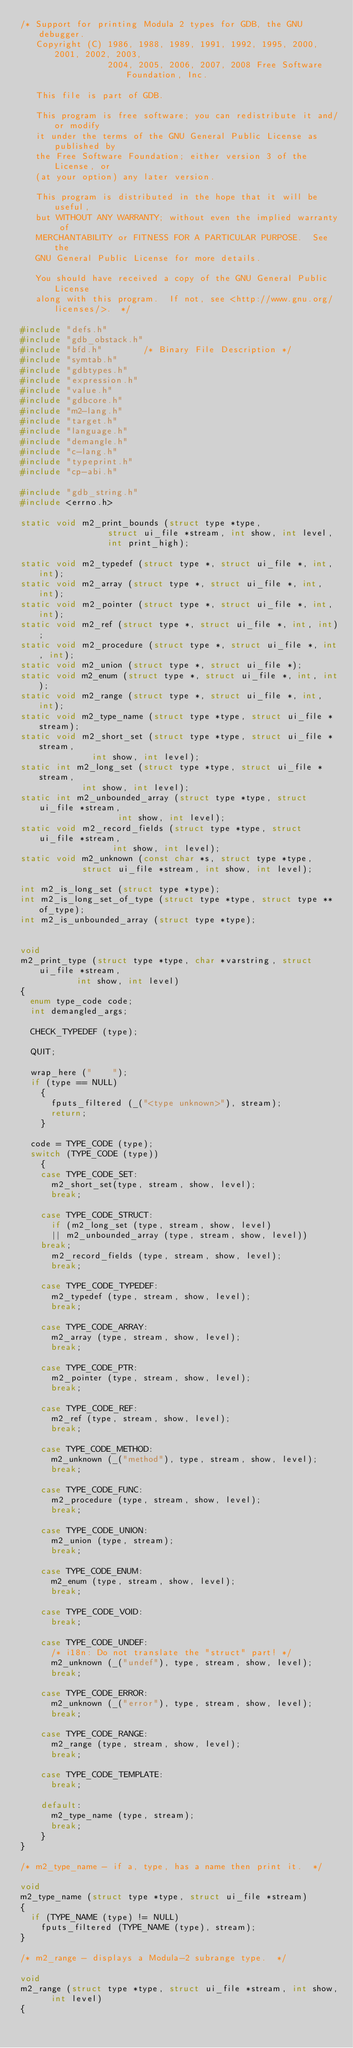<code> <loc_0><loc_0><loc_500><loc_500><_C_>/* Support for printing Modula 2 types for GDB, the GNU debugger.
   Copyright (C) 1986, 1988, 1989, 1991, 1992, 1995, 2000, 2001, 2002, 2003,
                 2004, 2005, 2006, 2007, 2008 Free Software Foundation, Inc.

   This file is part of GDB.

   This program is free software; you can redistribute it and/or modify
   it under the terms of the GNU General Public License as published by
   the Free Software Foundation; either version 3 of the License, or
   (at your option) any later version.

   This program is distributed in the hope that it will be useful,
   but WITHOUT ANY WARRANTY; without even the implied warranty of
   MERCHANTABILITY or FITNESS FOR A PARTICULAR PURPOSE.  See the
   GNU General Public License for more details.

   You should have received a copy of the GNU General Public License
   along with this program.  If not, see <http://www.gnu.org/licenses/>.  */

#include "defs.h"
#include "gdb_obstack.h"
#include "bfd.h"		/* Binary File Description */
#include "symtab.h"
#include "gdbtypes.h"
#include "expression.h"
#include "value.h"
#include "gdbcore.h"
#include "m2-lang.h"
#include "target.h"
#include "language.h"
#include "demangle.h"
#include "c-lang.h"
#include "typeprint.h"
#include "cp-abi.h"

#include "gdb_string.h"
#include <errno.h>

static void m2_print_bounds (struct type *type,
			     struct ui_file *stream, int show, int level,
			     int print_high);

static void m2_typedef (struct type *, struct ui_file *, int, int);
static void m2_array (struct type *, struct ui_file *, int, int);
static void m2_pointer (struct type *, struct ui_file *, int, int);
static void m2_ref (struct type *, struct ui_file *, int, int);
static void m2_procedure (struct type *, struct ui_file *, int, int);
static void m2_union (struct type *, struct ui_file *);
static void m2_enum (struct type *, struct ui_file *, int, int);
static void m2_range (struct type *, struct ui_file *, int, int);
static void m2_type_name (struct type *type, struct ui_file *stream);
static void m2_short_set (struct type *type, struct ui_file *stream,
			  int show, int level);
static int m2_long_set (struct type *type, struct ui_file *stream,
			int show, int level);
static int m2_unbounded_array (struct type *type, struct ui_file *stream,
			       int show, int level);
static void m2_record_fields (struct type *type, struct ui_file *stream,
			      int show, int level);
static void m2_unknown (const char *s, struct type *type,
			struct ui_file *stream, int show, int level);

int m2_is_long_set (struct type *type);
int m2_is_long_set_of_type (struct type *type, struct type **of_type);
int m2_is_unbounded_array (struct type *type);


void
m2_print_type (struct type *type, char *varstring, struct ui_file *stream,
	       int show, int level)
{
  enum type_code code;
  int demangled_args;

  CHECK_TYPEDEF (type);

  QUIT;

  wrap_here ("    ");
  if (type == NULL)
    {
      fputs_filtered (_("<type unknown>"), stream);
      return;
    }

  code = TYPE_CODE (type);
  switch (TYPE_CODE (type))
    {
    case TYPE_CODE_SET:
      m2_short_set(type, stream, show, level);
      break;

    case TYPE_CODE_STRUCT:
      if (m2_long_set (type, stream, show, level)
	  || m2_unbounded_array (type, stream, show, level))
	break;
      m2_record_fields (type, stream, show, level);
      break;

    case TYPE_CODE_TYPEDEF:
      m2_typedef (type, stream, show, level);
      break;

    case TYPE_CODE_ARRAY:
      m2_array (type, stream, show, level);
      break;

    case TYPE_CODE_PTR:
      m2_pointer (type, stream, show, level);
      break;

    case TYPE_CODE_REF:
      m2_ref (type, stream, show, level);
      break;

    case TYPE_CODE_METHOD:
      m2_unknown (_("method"), type, stream, show, level);
      break;

    case TYPE_CODE_FUNC:
      m2_procedure (type, stream, show, level);
      break;

    case TYPE_CODE_UNION:
      m2_union (type, stream);
      break;

    case TYPE_CODE_ENUM:
      m2_enum (type, stream, show, level);
      break;

    case TYPE_CODE_VOID:
      break;

    case TYPE_CODE_UNDEF:
      /* i18n: Do not translate the "struct" part! */
      m2_unknown (_("undef"), type, stream, show, level);
      break;

    case TYPE_CODE_ERROR:
      m2_unknown (_("error"), type, stream, show, level);
      break;

    case TYPE_CODE_RANGE:
      m2_range (type, stream, show, level);
      break;

    case TYPE_CODE_TEMPLATE:
      break;

    default:
      m2_type_name (type, stream);
      break;
    }
}

/* m2_type_name - if a, type, has a name then print it.  */

void
m2_type_name (struct type *type, struct ui_file *stream)
{
  if (TYPE_NAME (type) != NULL)
    fputs_filtered (TYPE_NAME (type), stream);
}

/* m2_range - displays a Modula-2 subrange type.  */

void
m2_range (struct type *type, struct ui_file *stream, int show,
	  int level)
{</code> 